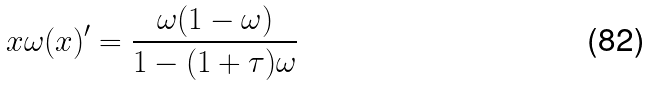<formula> <loc_0><loc_0><loc_500><loc_500>x \omega ( x ) ^ { \prime } = \frac { \omega ( 1 - \omega ) } { 1 - ( 1 + \tau ) \omega }</formula> 